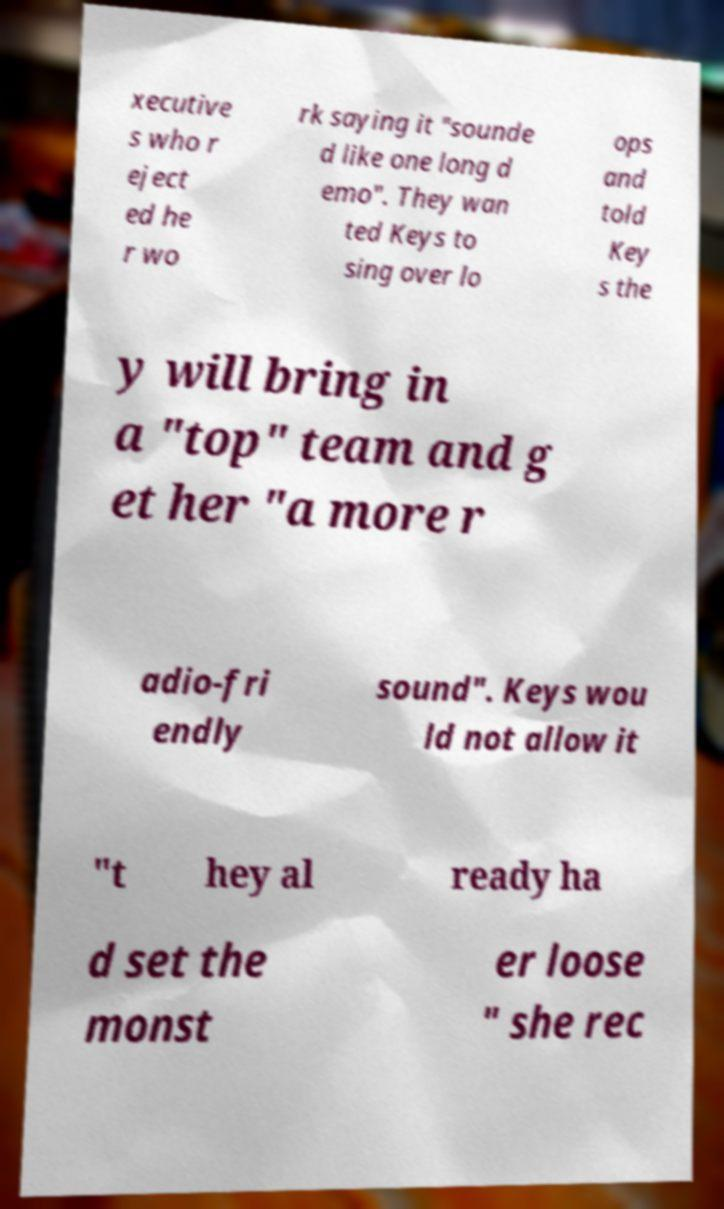Could you extract and type out the text from this image? xecutive s who r eject ed he r wo rk saying it "sounde d like one long d emo". They wan ted Keys to sing over lo ops and told Key s the y will bring in a "top" team and g et her "a more r adio-fri endly sound". Keys wou ld not allow it "t hey al ready ha d set the monst er loose " she rec 